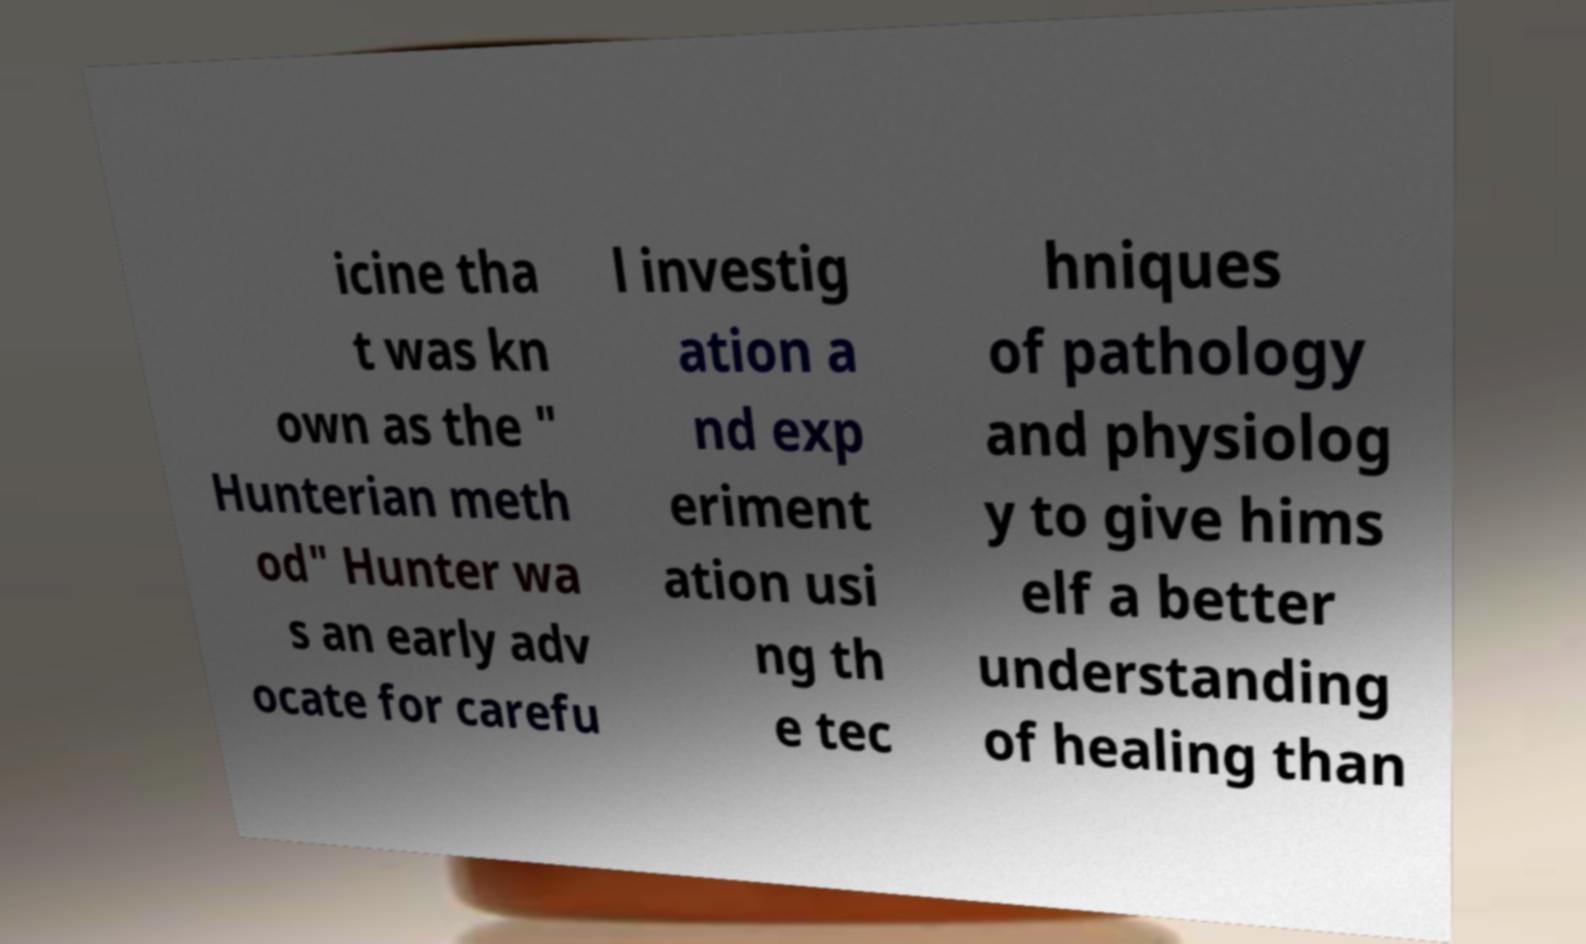Can you read and provide the text displayed in the image?This photo seems to have some interesting text. Can you extract and type it out for me? icine tha t was kn own as the " Hunterian meth od" Hunter wa s an early adv ocate for carefu l investig ation a nd exp eriment ation usi ng th e tec hniques of pathology and physiolog y to give hims elf a better understanding of healing than 